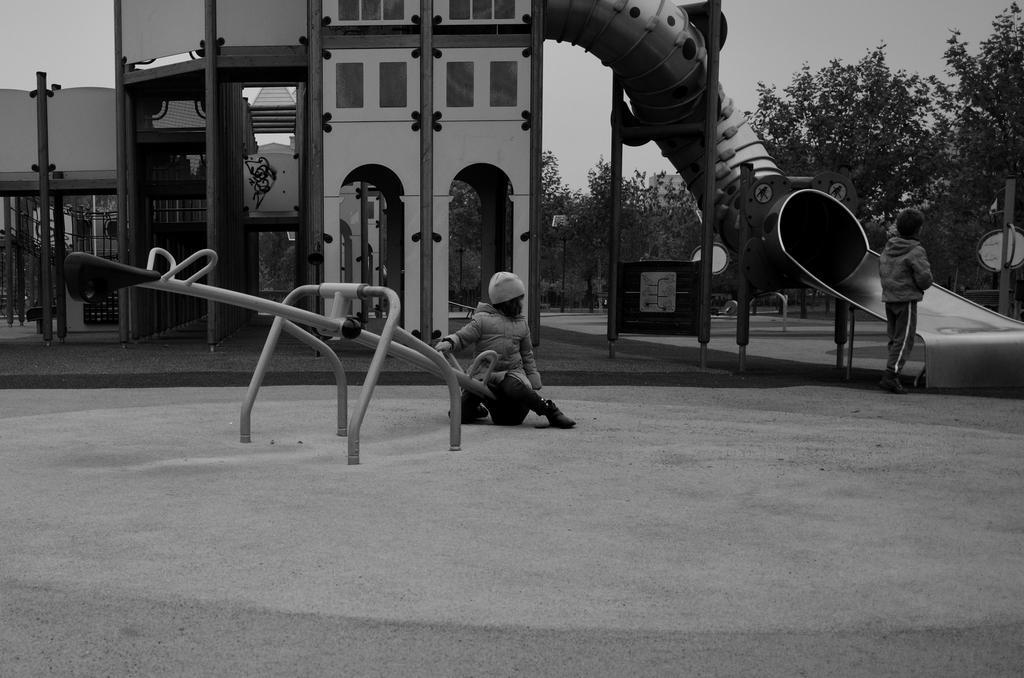Could you give a brief overview of what you see in this image? This is a black and white image. In the center of the image there is a girl on a ride. In the background of the image there is a house. There are rides. There are trees. There is a boy standing to the right side of the image. At the bottom of the image there is floor. 